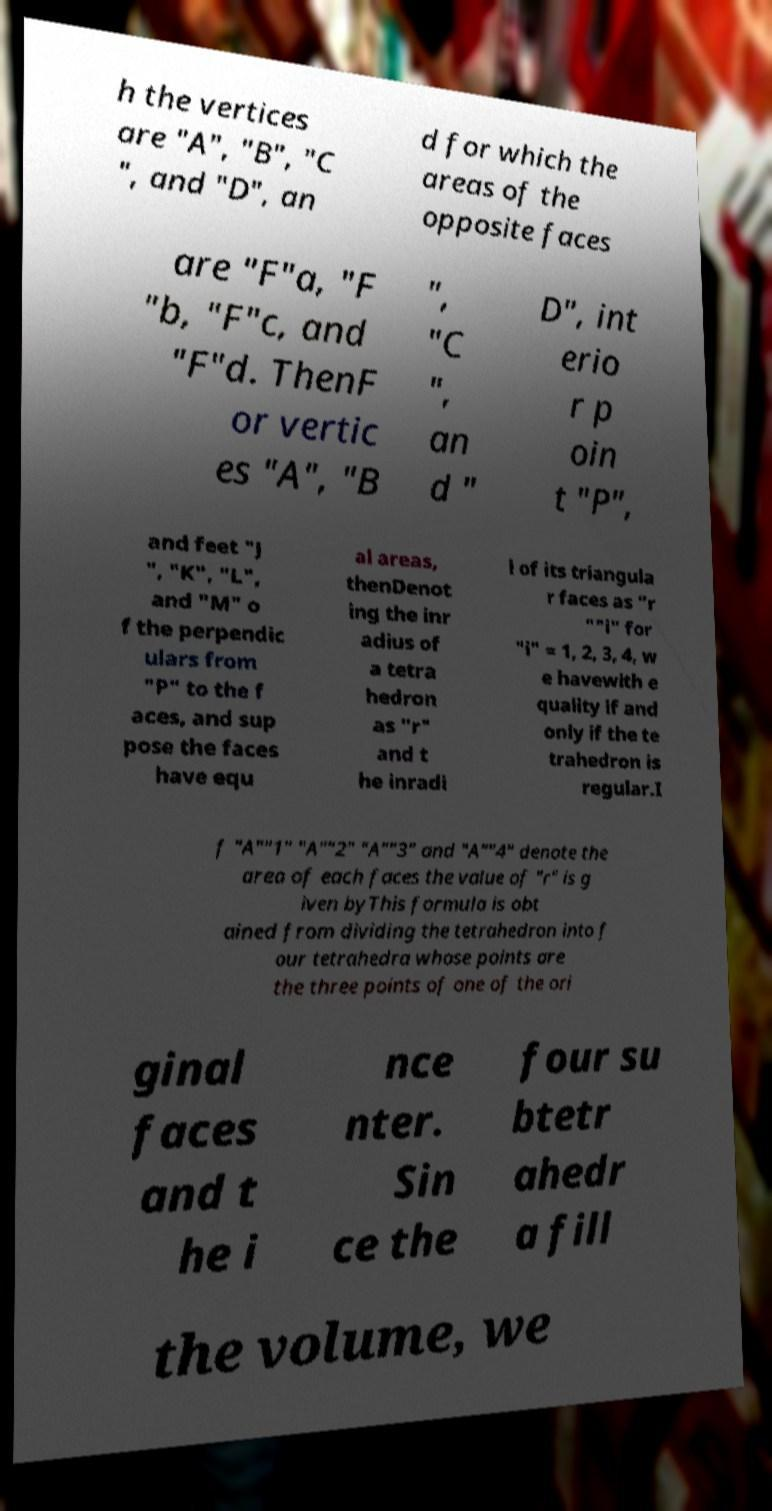Can you read and provide the text displayed in the image?This photo seems to have some interesting text. Can you extract and type it out for me? h the vertices are "A", "B", "C ", and "D", an d for which the areas of the opposite faces are "F"a, "F "b, "F"c, and "F"d. ThenF or vertic es "A", "B ", "C ", an d " D", int erio r p oin t "P", and feet "J ", "K", "L", and "M" o f the perpendic ulars from "P" to the f aces, and sup pose the faces have equ al areas, thenDenot ing the inr adius of a tetra hedron as "r" and t he inradi i of its triangula r faces as "r ""i" for "i" = 1, 2, 3, 4, w e havewith e quality if and only if the te trahedron is regular.I f "A""1" "A""2" "A""3" and "A""4" denote the area of each faces the value of "r" is g iven byThis formula is obt ained from dividing the tetrahedron into f our tetrahedra whose points are the three points of one of the ori ginal faces and t he i nce nter. Sin ce the four su btetr ahedr a fill the volume, we 